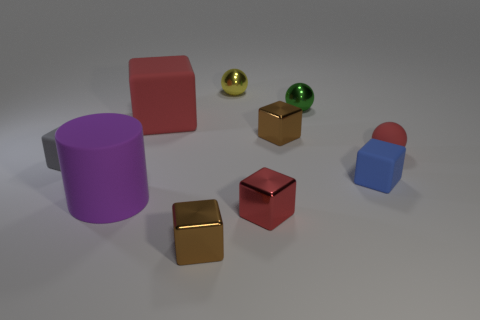Subtract all blue cubes. How many cubes are left? 5 Subtract all red blocks. How many blocks are left? 4 Subtract all cyan blocks. Subtract all purple cylinders. How many blocks are left? 6 Subtract all balls. How many objects are left? 7 Subtract all cyan metallic spheres. Subtract all tiny red rubber things. How many objects are left? 9 Add 1 tiny yellow shiny things. How many tiny yellow shiny things are left? 2 Add 1 small blue rubber things. How many small blue rubber things exist? 2 Subtract 0 purple blocks. How many objects are left? 10 